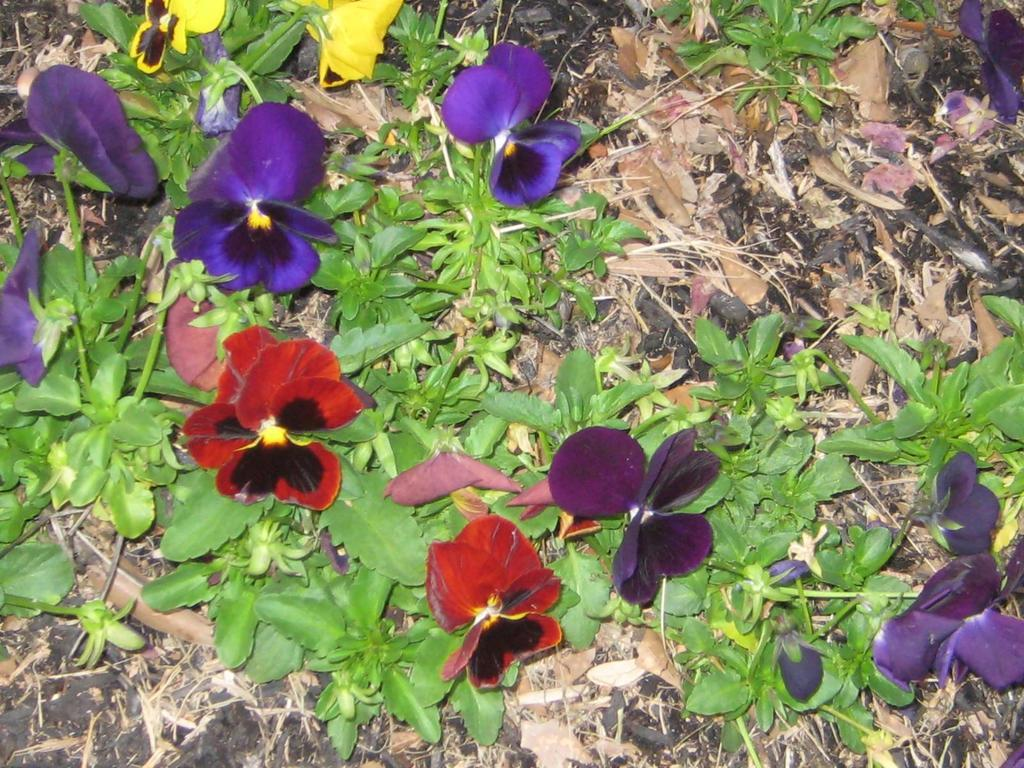What colors are the flowers in the image? The flowers in the image are purple and red. What are the flowers attached to? The flowers are part of plants. Where are the plants located in the image? The plants are on the ground. What type of jar is used to burn the flowers in the image? There is no jar or burning of flowers present in the image. 